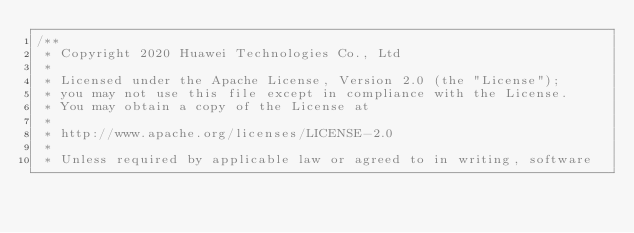Convert code to text. <code><loc_0><loc_0><loc_500><loc_500><_C_>/**
 * Copyright 2020 Huawei Technologies Co., Ltd
 *
 * Licensed under the Apache License, Version 2.0 (the "License");
 * you may not use this file except in compliance with the License.
 * You may obtain a copy of the License at
 *
 * http://www.apache.org/licenses/LICENSE-2.0
 *
 * Unless required by applicable law or agreed to in writing, software</code> 